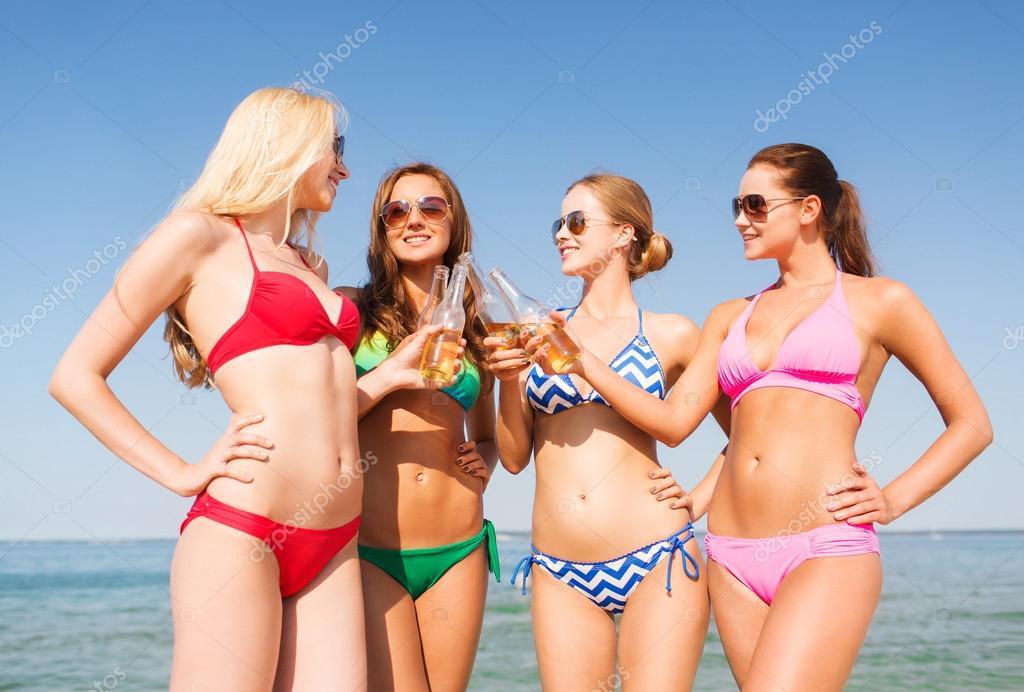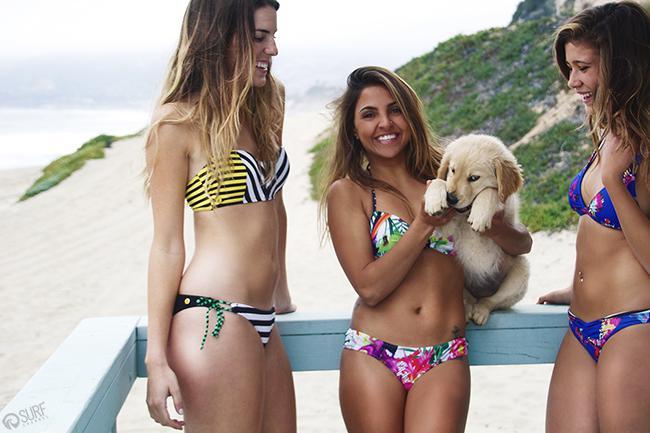The first image is the image on the left, the second image is the image on the right. For the images displayed, is the sentence "There are eight or less women." factually correct? Answer yes or no. Yes. The first image is the image on the left, the second image is the image on the right. Evaluate the accuracy of this statement regarding the images: "One image shows four bikini models in sunglasses standing in front of the ocean.". Is it true? Answer yes or no. Yes. 